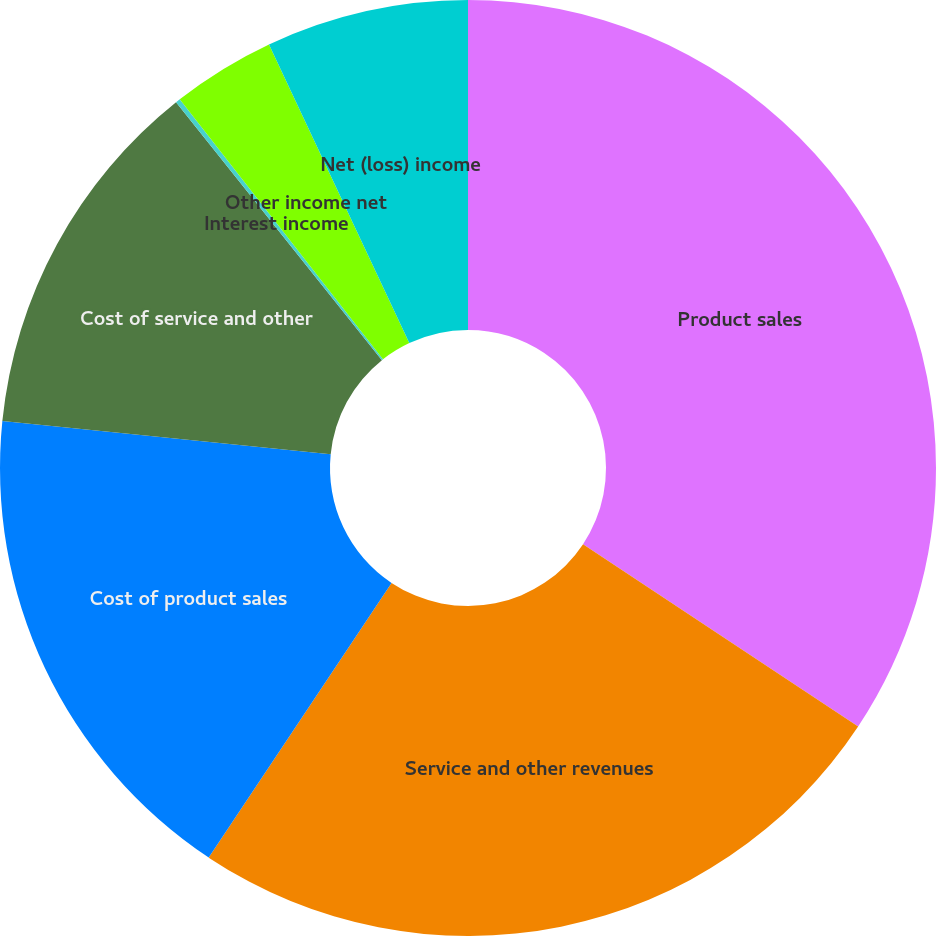Convert chart. <chart><loc_0><loc_0><loc_500><loc_500><pie_chart><fcel>Product sales<fcel>Service and other revenues<fcel>Cost of product sales<fcel>Cost of service and other<fcel>Interest income<fcel>Other income net<fcel>Net (loss) income<nl><fcel>34.31%<fcel>25.03%<fcel>17.25%<fcel>12.68%<fcel>0.16%<fcel>3.57%<fcel>6.99%<nl></chart> 